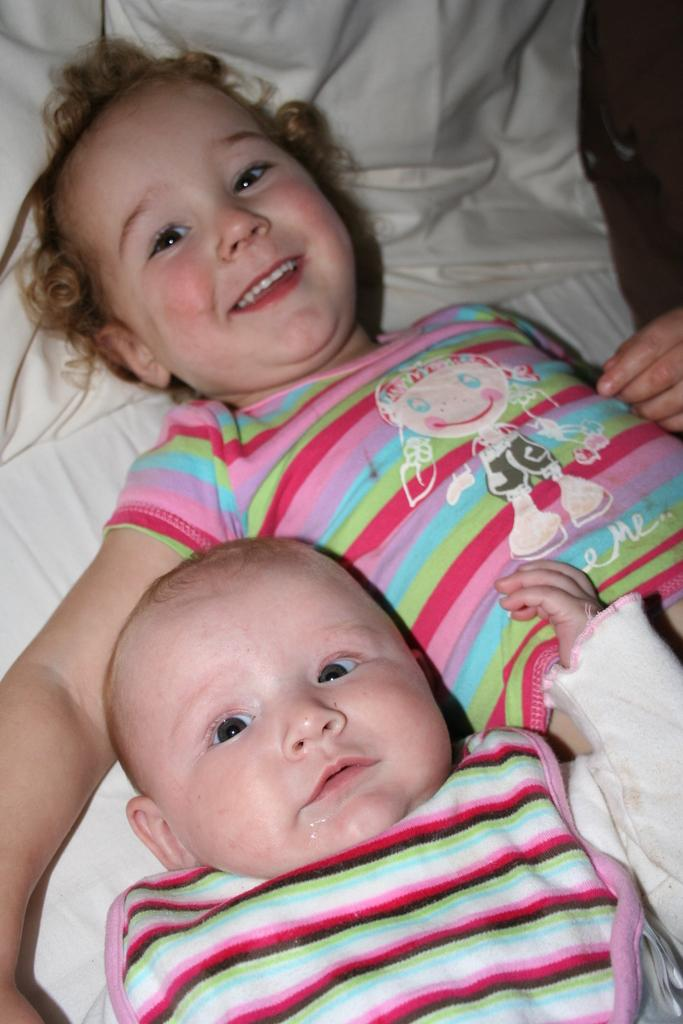What are the main subjects in the image? There is a kid and a baby in the picture. Where are the kid and the baby located in the image? Both the kid and the baby are laying on a bed. What type of fork can be seen in the image? There is no fork present in the image. What is the cause of the thunder in the image? There is no thunder present in the image. 